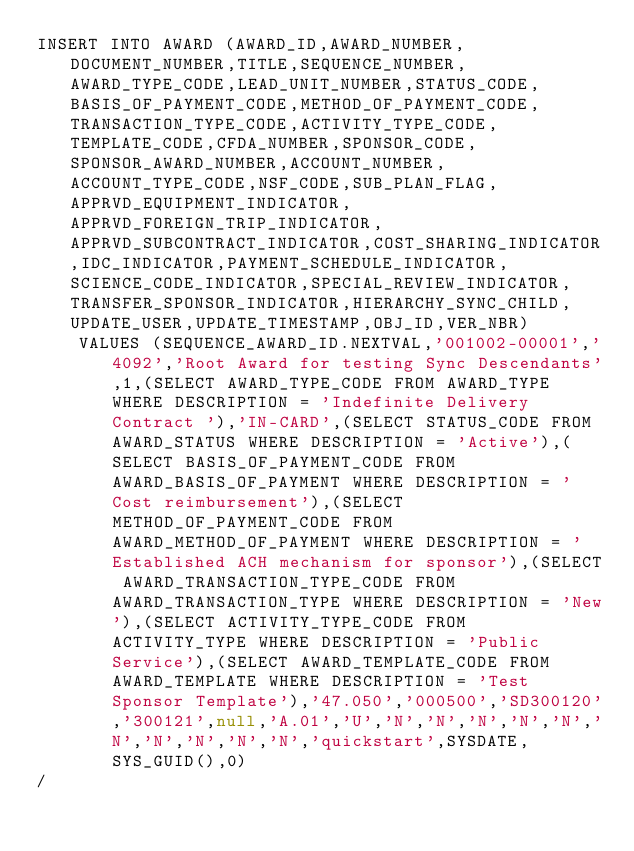Convert code to text. <code><loc_0><loc_0><loc_500><loc_500><_SQL_>INSERT INTO AWARD (AWARD_ID,AWARD_NUMBER,DOCUMENT_NUMBER,TITLE,SEQUENCE_NUMBER,AWARD_TYPE_CODE,LEAD_UNIT_NUMBER,STATUS_CODE,BASIS_OF_PAYMENT_CODE,METHOD_OF_PAYMENT_CODE,TRANSACTION_TYPE_CODE,ACTIVITY_TYPE_CODE,TEMPLATE_CODE,CFDA_NUMBER,SPONSOR_CODE,SPONSOR_AWARD_NUMBER,ACCOUNT_NUMBER,ACCOUNT_TYPE_CODE,NSF_CODE,SUB_PLAN_FLAG,APPRVD_EQUIPMENT_INDICATOR,APPRVD_FOREIGN_TRIP_INDICATOR,APPRVD_SUBCONTRACT_INDICATOR,COST_SHARING_INDICATOR,IDC_INDICATOR,PAYMENT_SCHEDULE_INDICATOR,SCIENCE_CODE_INDICATOR,SPECIAL_REVIEW_INDICATOR,TRANSFER_SPONSOR_INDICATOR,HIERARCHY_SYNC_CHILD,UPDATE_USER,UPDATE_TIMESTAMP,OBJ_ID,VER_NBR) 
    VALUES (SEQUENCE_AWARD_ID.NEXTVAL,'001002-00001','4092','Root Award for testing Sync Descendants',1,(SELECT AWARD_TYPE_CODE FROM AWARD_TYPE WHERE DESCRIPTION = 'Indefinite Delivery Contract '),'IN-CARD',(SELECT STATUS_CODE FROM AWARD_STATUS WHERE DESCRIPTION = 'Active'),(SELECT BASIS_OF_PAYMENT_CODE FROM AWARD_BASIS_OF_PAYMENT WHERE DESCRIPTION = 'Cost reimbursement'),(SELECT METHOD_OF_PAYMENT_CODE FROM AWARD_METHOD_OF_PAYMENT WHERE DESCRIPTION = 'Established ACH mechanism for sponsor'),(SELECT AWARD_TRANSACTION_TYPE_CODE FROM AWARD_TRANSACTION_TYPE WHERE DESCRIPTION = 'New'),(SELECT ACTIVITY_TYPE_CODE FROM ACTIVITY_TYPE WHERE DESCRIPTION = 'Public Service'),(SELECT AWARD_TEMPLATE_CODE FROM AWARD_TEMPLATE WHERE DESCRIPTION = 'Test Sponsor Template'),'47.050','000500','SD300120','300121',null,'A.01','U','N','N','N','N','N','N','N','N','N','N','quickstart',SYSDATE,SYS_GUID(),0)
/</code> 